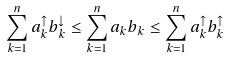<formula> <loc_0><loc_0><loc_500><loc_500>\sum _ { k = 1 } ^ { n } a ^ { \uparrow } _ { k } b ^ { \downarrow } _ { k } \leq \sum _ { k = 1 } ^ { n } a _ { k } b _ { k } \leq \sum _ { k = 1 } ^ { n } a ^ { \uparrow } _ { k } b ^ { \uparrow } _ { k }</formula> 